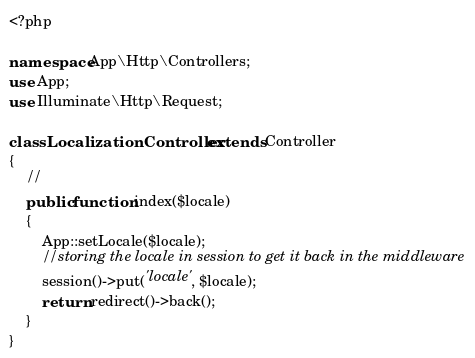<code> <loc_0><loc_0><loc_500><loc_500><_PHP_><?php

namespace App\Http\Controllers;
use App;
use Illuminate\Http\Request;

class LocalizationController extends Controller
{
    //
    public function index($locale)
    {
        App::setLocale($locale);
        //storing the locale in session to get it back in the middleware
        session()->put('locale', $locale);
        return redirect()->back();
    }
}
</code> 